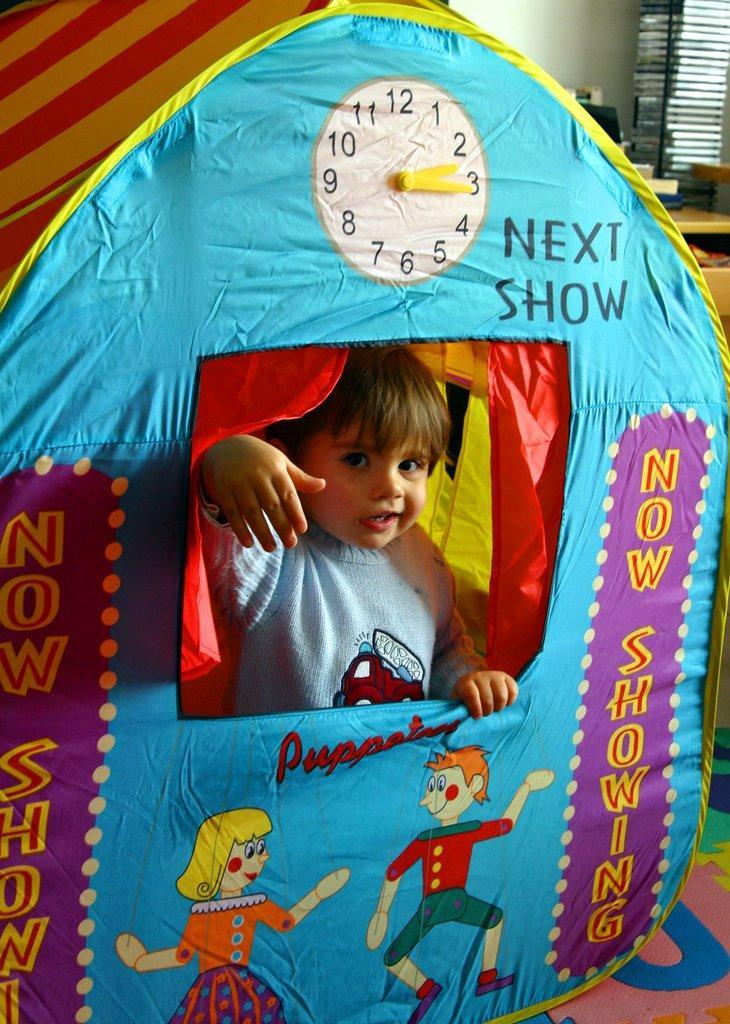Could you give a brief overview of what you see in this image? In this image I can see a tent house in multi color. I can see a clock and cartoons on it. One person is inside and wearing ash color dress. Back I can see few objects and white wall. 